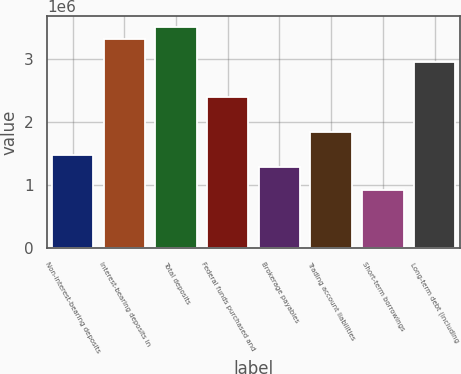<chart> <loc_0><loc_0><loc_500><loc_500><bar_chart><fcel>Non-interest-bearing deposits<fcel>Interest-bearing deposits in<fcel>Total deposits<fcel>Federal funds purchased and<fcel>Brokerage payables<fcel>Trading account liabilities<fcel>Short-term borrowings<fcel>Long-term debt (including<nl><fcel>1.47398e+06<fcel>3.31641e+06<fcel>3.50066e+06<fcel>2.3952e+06<fcel>1.28973e+06<fcel>1.84246e+06<fcel>921248<fcel>2.94793e+06<nl></chart> 